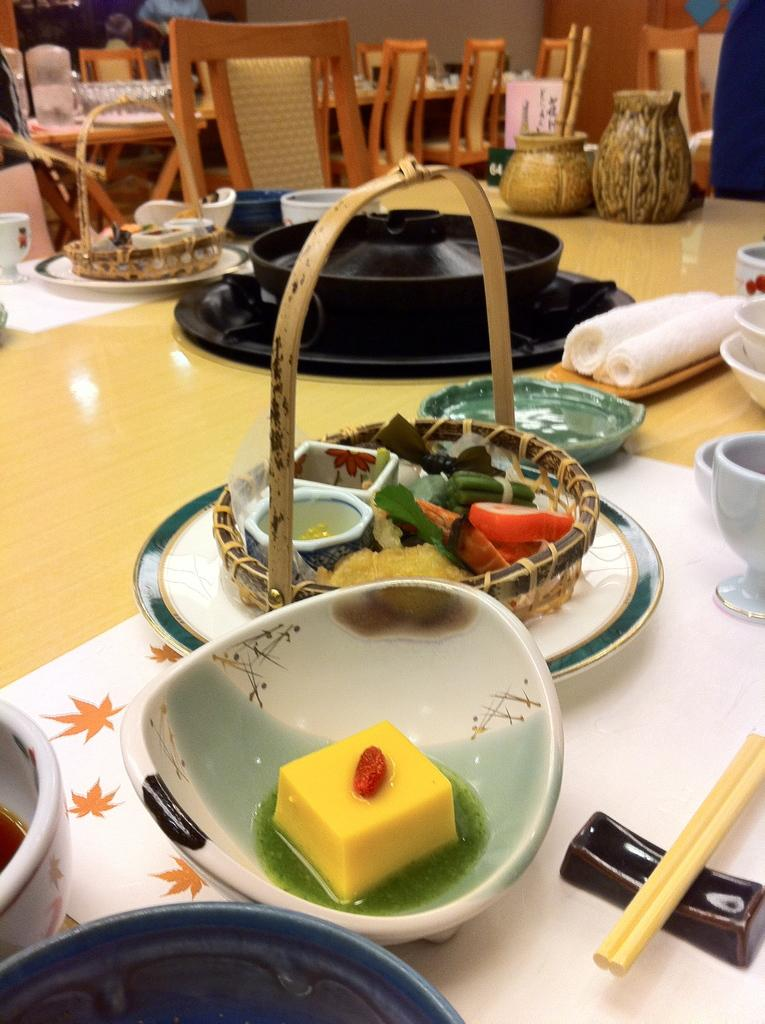What is on the table in the image? There is a bowl, chopsticks, and a basket on the table in the image. What is inside the bowl? The bowl contains a sweet. What is inside the basket? The basket contains food items. What can be seen in the background of the image? There are chairs and a table in the background. What type of stem can be seen growing from the sweet in the image? There is no stem growing from the sweet in the image; it is a sweet contained within a bowl. 